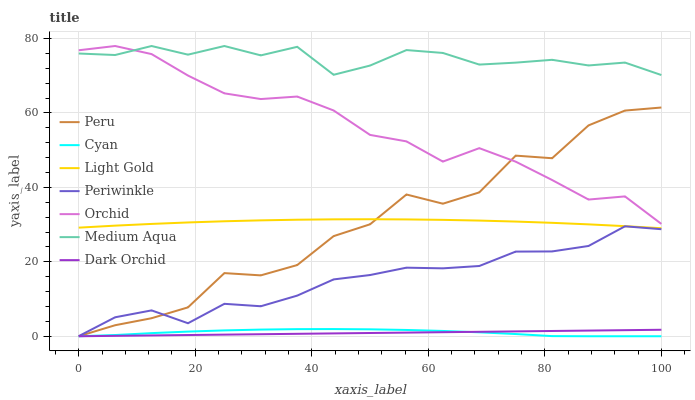Does Dark Orchid have the minimum area under the curve?
Answer yes or no. Yes. Does Medium Aqua have the maximum area under the curve?
Answer yes or no. Yes. Does Medium Aqua have the minimum area under the curve?
Answer yes or no. No. Does Dark Orchid have the maximum area under the curve?
Answer yes or no. No. Is Dark Orchid the smoothest?
Answer yes or no. Yes. Is Peru the roughest?
Answer yes or no. Yes. Is Medium Aqua the smoothest?
Answer yes or no. No. Is Medium Aqua the roughest?
Answer yes or no. No. Does Medium Aqua have the lowest value?
Answer yes or no. No. Does Orchid have the highest value?
Answer yes or no. Yes. Does Dark Orchid have the highest value?
Answer yes or no. No. Is Light Gold less than Medium Aqua?
Answer yes or no. Yes. Is Periwinkle greater than Cyan?
Answer yes or no. Yes. Does Peru intersect Periwinkle?
Answer yes or no. Yes. Is Peru less than Periwinkle?
Answer yes or no. No. Is Peru greater than Periwinkle?
Answer yes or no. No. Does Light Gold intersect Medium Aqua?
Answer yes or no. No. 